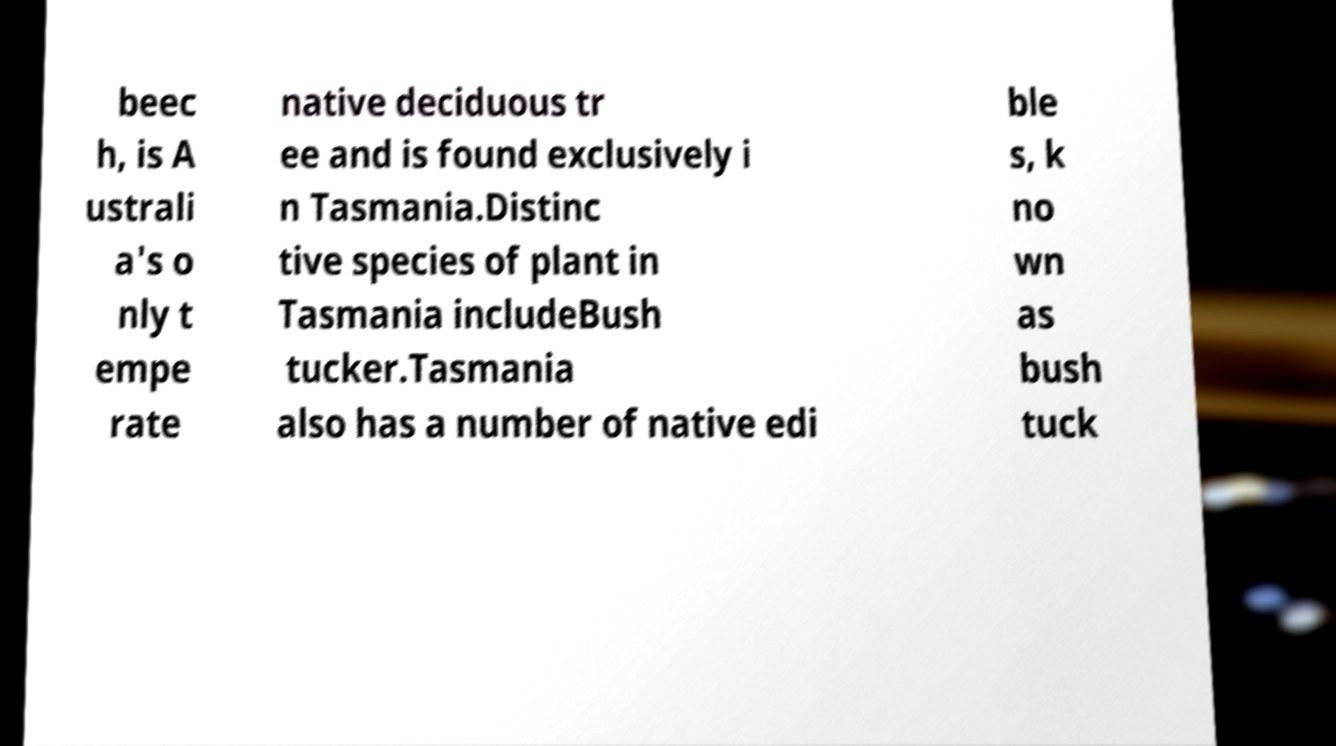Please read and relay the text visible in this image. What does it say? beec h, is A ustrali a's o nly t empe rate native deciduous tr ee and is found exclusively i n Tasmania.Distinc tive species of plant in Tasmania includeBush tucker.Tasmania also has a number of native edi ble s, k no wn as bush tuck 